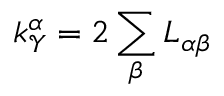Convert formula to latex. <formula><loc_0><loc_0><loc_500><loc_500>k _ { \mathcal { Y } } ^ { \alpha } = 2 \sum _ { \beta } L _ { \alpha \beta }</formula> 